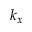<formula> <loc_0><loc_0><loc_500><loc_500>k _ { x }</formula> 